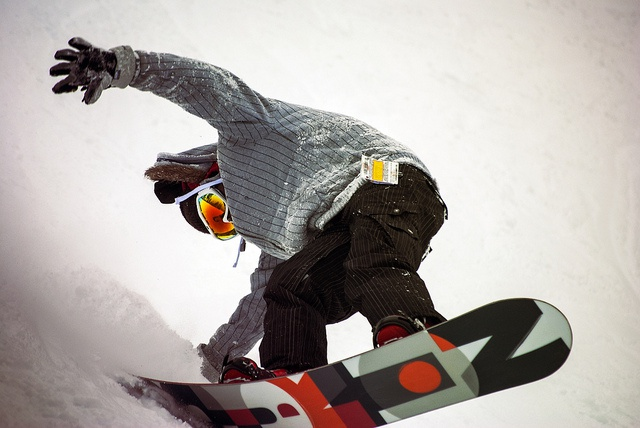Describe the objects in this image and their specific colors. I can see people in darkgray, black, gray, and lightgray tones and snowboard in darkgray, black, brown, and gray tones in this image. 